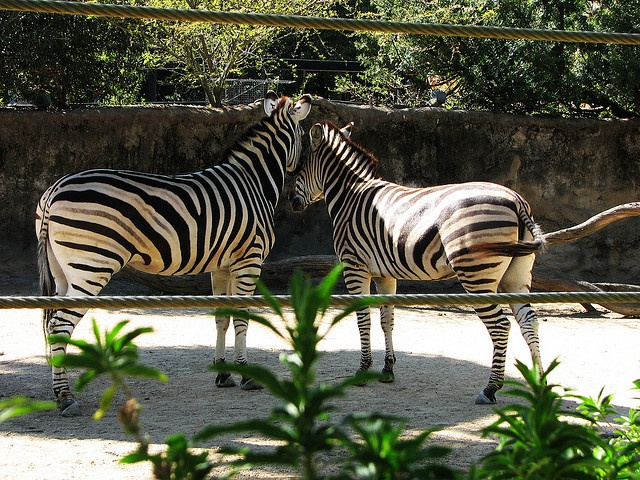Describe the objects in this image and their specific colors. I can see zebra in black, tan, gray, and darkgray tones and zebra in black, white, tan, and gray tones in this image. 